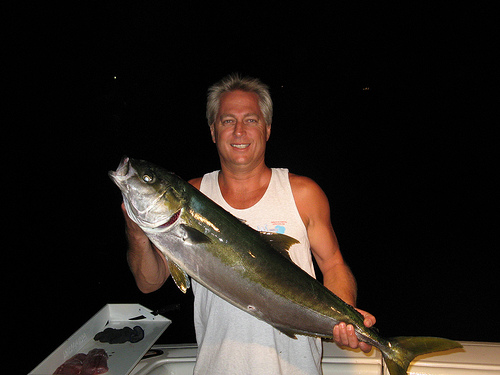<image>
Is the fish to the left of the man? No. The fish is not to the left of the man. From this viewpoint, they have a different horizontal relationship. Where is the fish in relation to the man? Is it in front of the man? Yes. The fish is positioned in front of the man, appearing closer to the camera viewpoint. 